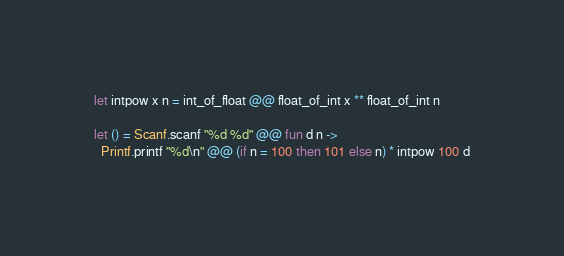<code> <loc_0><loc_0><loc_500><loc_500><_OCaml_>let intpow x n = int_of_float @@ float_of_int x ** float_of_int n

let () = Scanf.scanf "%d %d" @@ fun d n ->
  Printf.printf "%d\n" @@ (if n = 100 then 101 else n) * intpow 100 d
</code> 